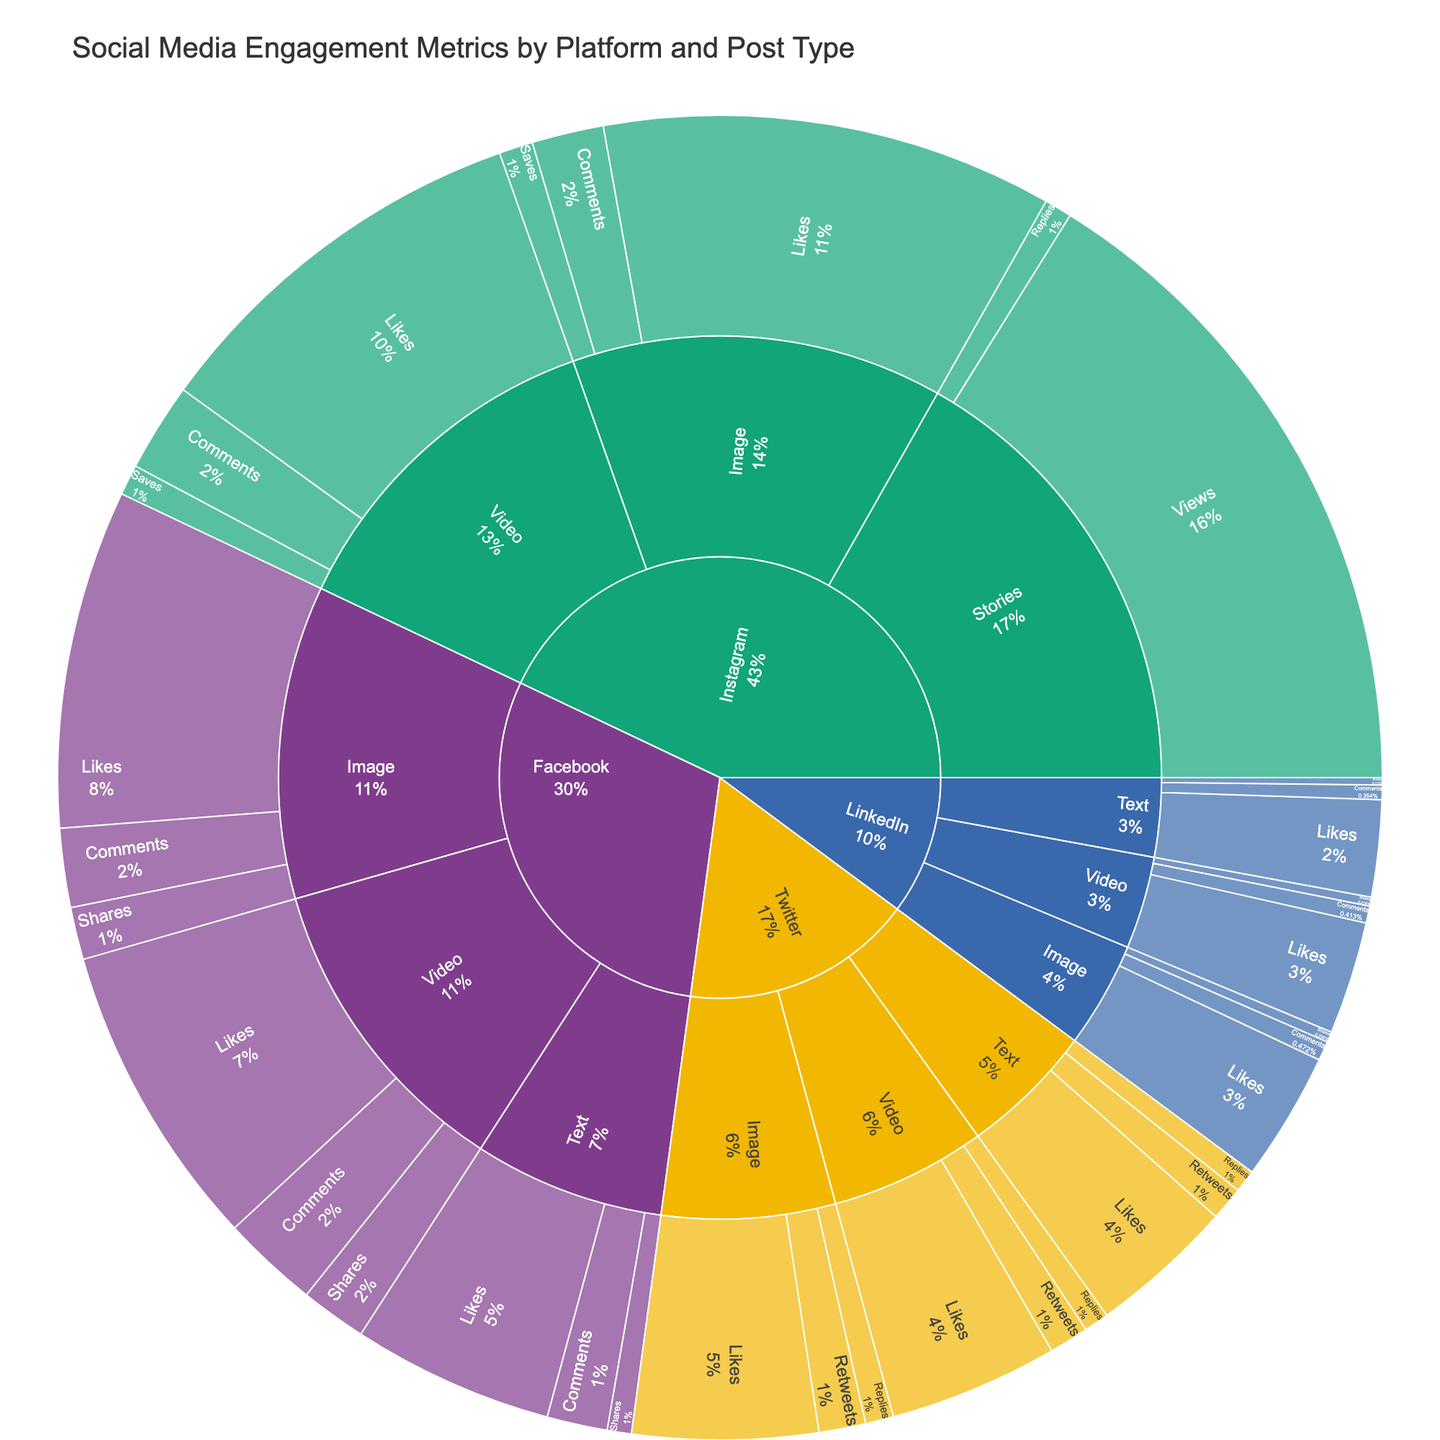What's the post type with the highest number of likes on Facebook? The sunburst plot shows various post types under Facebook with their metrics. Look for the segment that represents likes and compare the values. Image posts have 4,200 likes.
Answer: Image Which platform has the most engagement for video posts? To compare engagement, add likes, comments, shares (or saves, views) for video posts on each platform. Instagram has the highest total: 4,900 likes + 1,100 comments + 380 saves.
Answer: Instagram What's the primary engagement metric for Instagram Stories? The sunburst plot shows different metrics for Instagram Stories. Identify the primary metric by looking at the segment with the larger value. Views have 8,200.
Answer: Views How does engagement for text posts on LinkedIn compare to those on Twitter? Sum the metrics (likes, comments, shares/retweets, replies) for text posts on LinkedIn and Twitter. LinkedIn has 1,200 + 180 + 90 = 1,470; Twitter has 1,800 + 420 + 280 = 2,500.
Answer: Twitter is higher Which platform has the smallest share for image posts, and what is its value? For each platform, sum the image post values (likes, comments, shares/retweets). LinkedIn has the smallest total: 1,600 + 240 + 130 = 1,970.
Answer: LinkedIn - 1,970 What's the total engagement for video posts across all platforms? Add the values for video posts on each platform's video segment. Facebook: 3,800 + 1,200 + 820; Instagram: 4,900 + 1,100 + 380; Twitter: 2,100 + 490 + 310; LinkedIn: 1,400 + 210 + 110.
Answer: 17,820 